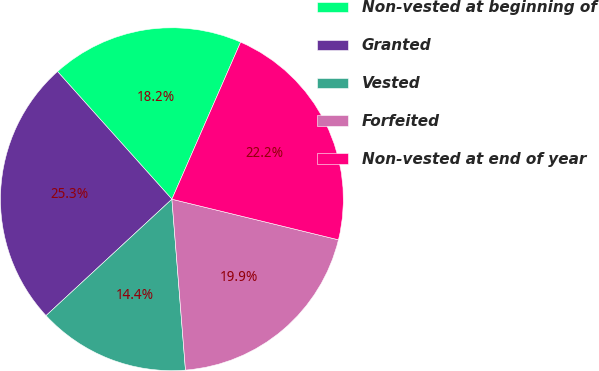Convert chart to OTSL. <chart><loc_0><loc_0><loc_500><loc_500><pie_chart><fcel>Non-vested at beginning of<fcel>Granted<fcel>Vested<fcel>Forfeited<fcel>Non-vested at end of year<nl><fcel>18.19%<fcel>25.25%<fcel>14.38%<fcel>19.93%<fcel>22.24%<nl></chart> 